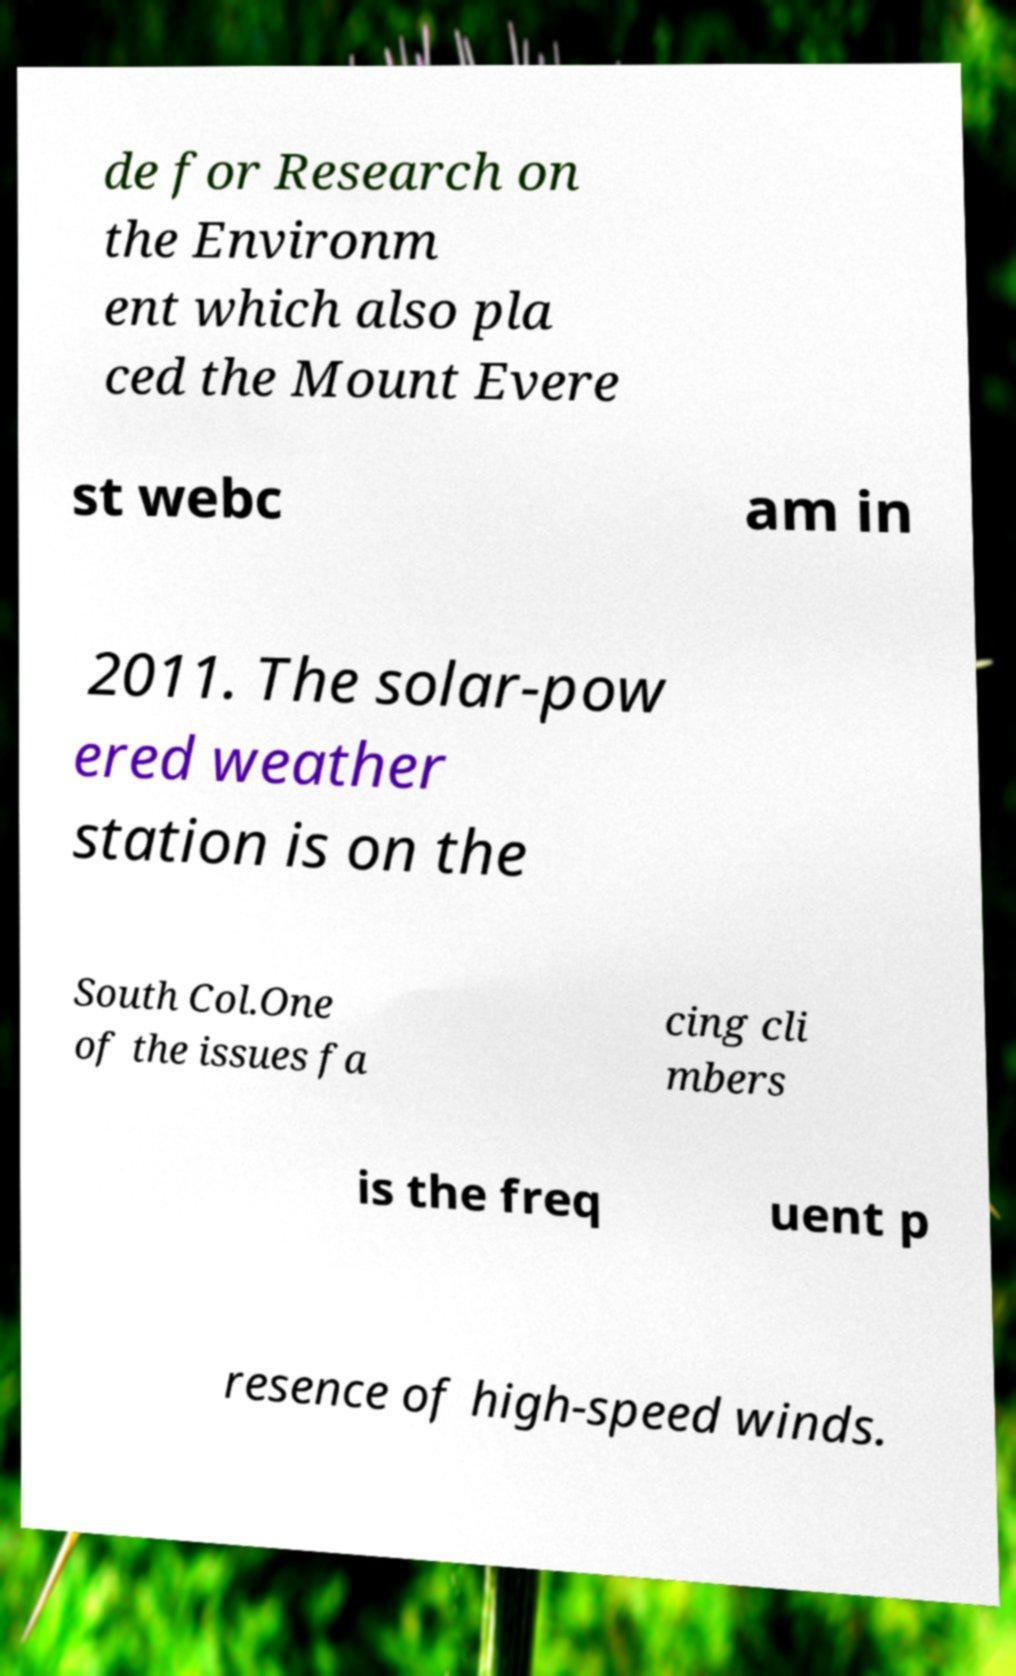Please identify and transcribe the text found in this image. de for Research on the Environm ent which also pla ced the Mount Evere st webc am in 2011. The solar-pow ered weather station is on the South Col.One of the issues fa cing cli mbers is the freq uent p resence of high-speed winds. 